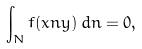<formula> <loc_0><loc_0><loc_500><loc_500>\int _ { N } f ( x n y ) \, d n = 0 ,</formula> 